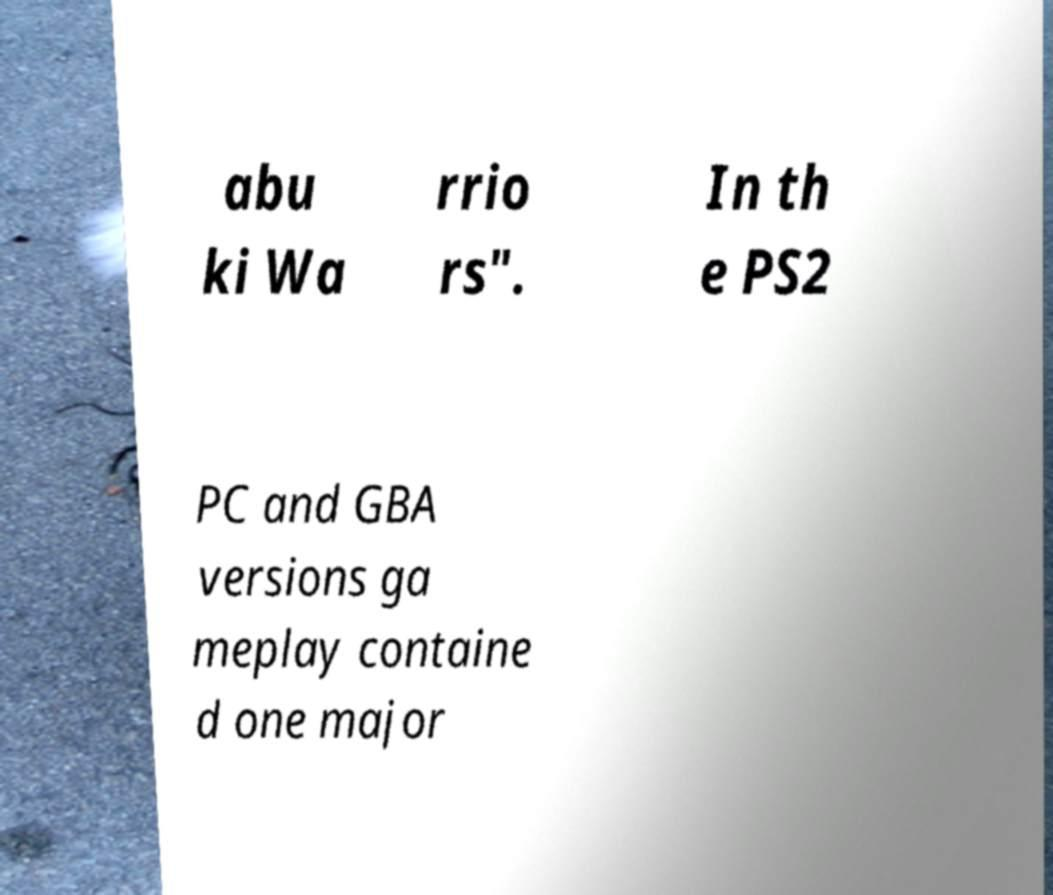Could you extract and type out the text from this image? abu ki Wa rrio rs". In th e PS2 PC and GBA versions ga meplay containe d one major 